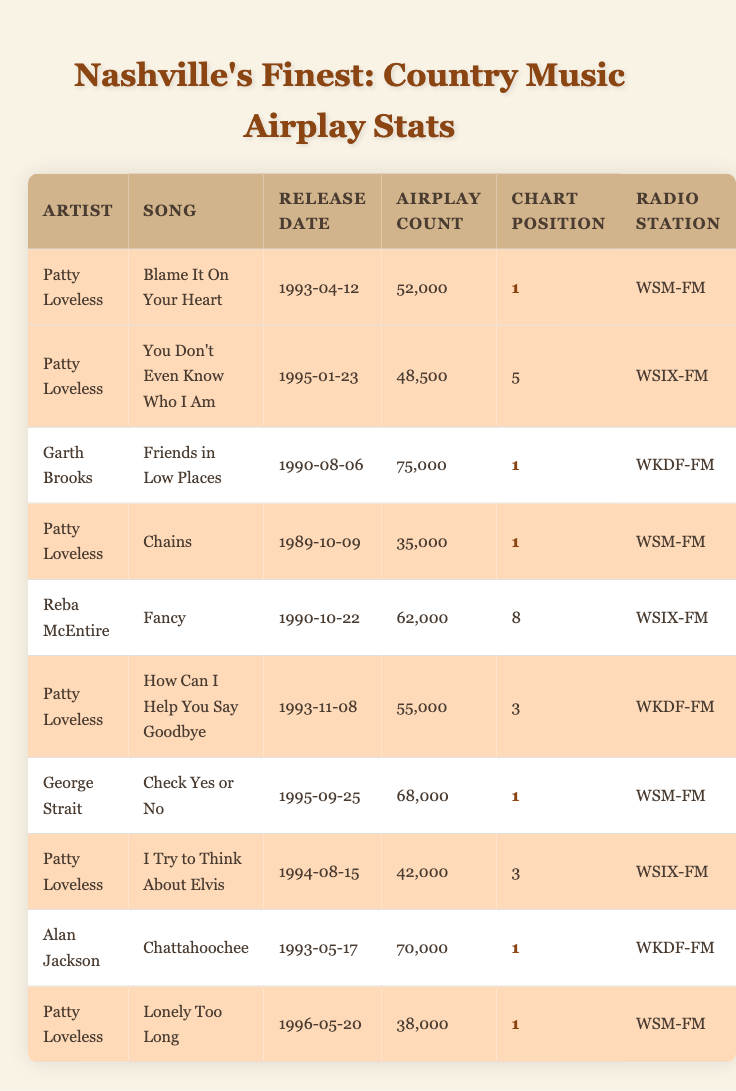What is the total airplay count for Patty Loveless' songs? There are four songs by Patty Loveless in the table—"Blame It On Your Heart" (52000), "You Don't Even Know Who I Am" (48500), "Chains" (35000), "How Can I Help You Say Goodbye" (55000), "I Try to Think About Elvis" (42000), and "Lonely Too Long" (38000). Adding these values gives a total airplay count of 52000 + 48500 + 35000 + 55000 + 42000 + 38000 = 270500.
Answer: 270500 Which song had the highest airplay count? By reviewing the airplay counts in the table, "Friends in Low Places" by Garth Brooks has the highest airplay count at 75000, compared to others like "Blame It On Your Heart" (52000) and "Chattahoochee" (70000).
Answer: Friends in Low Places Did Patty Loveless ever reach the top chart position with her songs? Upon reviewing the songs listed in the table, "Blame It On Your Heart," "Chains," "Lonely Too Long," and others achieved the chart position of 1, confirming that yes, Patty Loveless reached the top of the charts.
Answer: Yes What is the average airplay count for Patty Loveless' songs? The airplay counts for Patty Loveless' songs are 52000, 48500, 35000, 55000, 42000, and 38000. The total airplay count is 270500, and since there are 6 songs, the average is 270500 / 6 = 45083.33.
Answer: 45083.33 How many songs by Garth Brooks are listed in the table? In the table, there is only one song by Garth Brooks, which is "Friends in Low Places." This confirms that Garth Brooks has one entry in the data.
Answer: 1 What is the release date of the song with the highest airplay count? The song with the highest airplay count is "Friends in Low Places" by Garth Brooks, which was released on 1990-08-06.
Answer: 1990-08-06 Which artist had multiple songs reaching the chart position of 1? Reviewing the data, Patty Loveless has four songs—"Blame It On Your Heart," "Chains," "Lonely Too Long," and "How Can I Help You Say Goodbye" all reaching the chart position of 1, while Garth Brooks and George Strait each have one song at that position. Thus, the answer is Patty Loveless.
Answer: Patty Loveless Did Reba McEntire have any songs that reached the chart position of 1? Looking at the data for Reba McEntire, her song "Fancy" reached a chart position of 8, which shows she did not have any songs reach the top chart position of 1.
Answer: No 